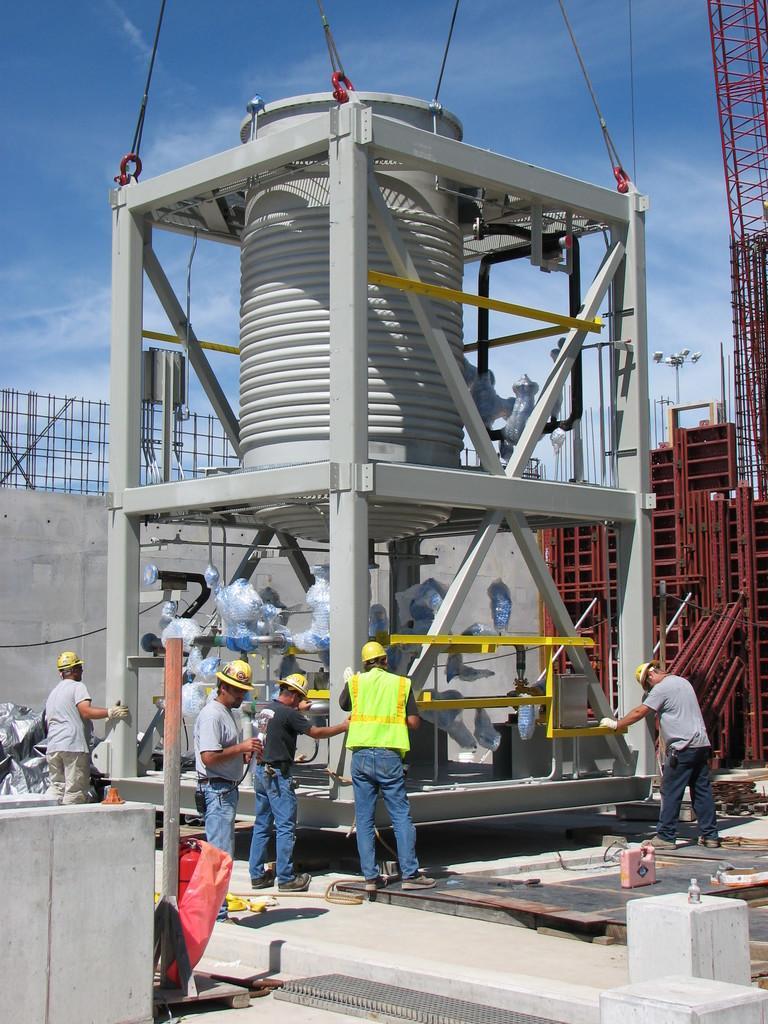Can you describe this image briefly? There are few persons standing in front of an object and there are few rows which are red in color in the right corner. 